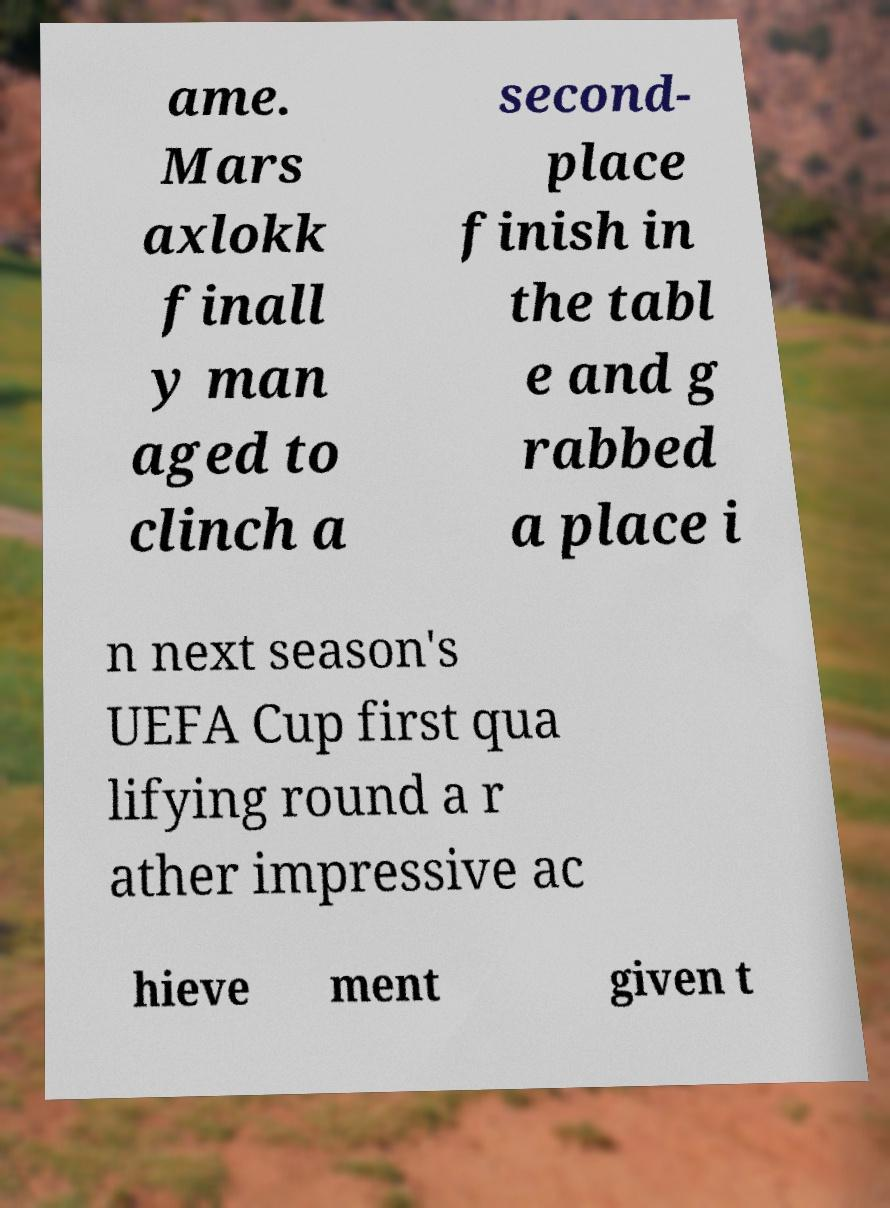Could you assist in decoding the text presented in this image and type it out clearly? ame. Mars axlokk finall y man aged to clinch a second- place finish in the tabl e and g rabbed a place i n next season's UEFA Cup first qua lifying round a r ather impressive ac hieve ment given t 